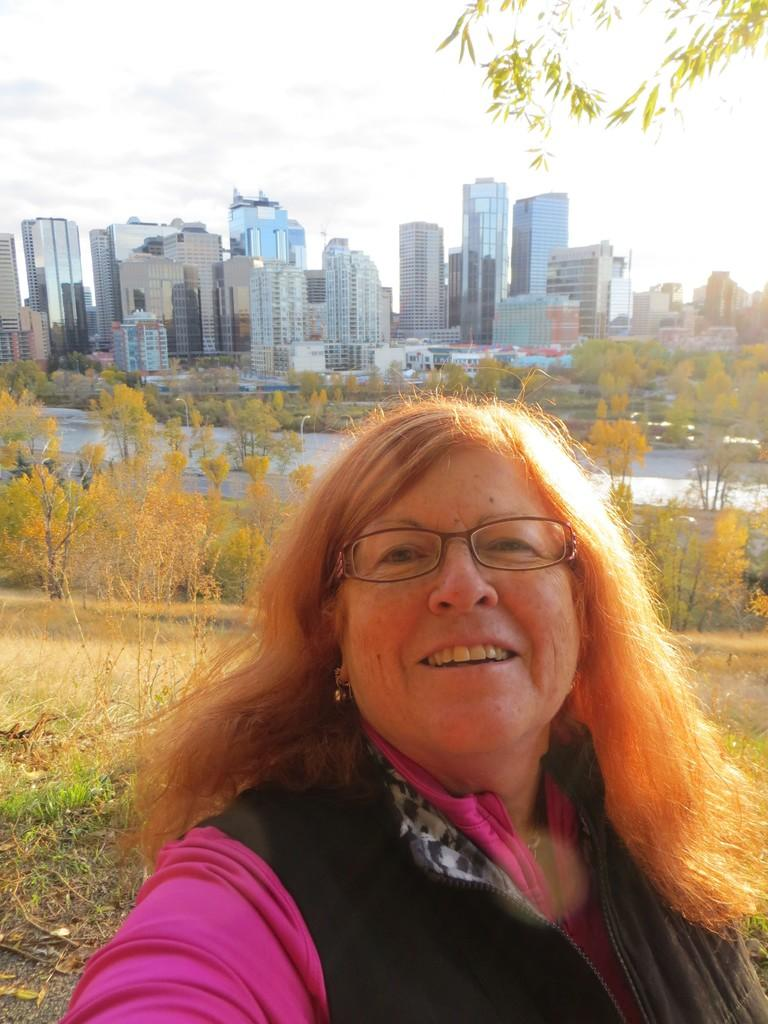Who is present in the image? There is a woman in the image. What is the woman wearing in the image? The woman is wearing a jacket and glasses (specs) in the image. What can be seen in the background of the image? There is grass, trees, buildings, and the sky visible in the background of the image. What type of boat is visible in the middle of the image? There is no boat present in the image; it features a woman wearing a jacket and glasses, with a background of grass, trees, buildings, and the sky. 